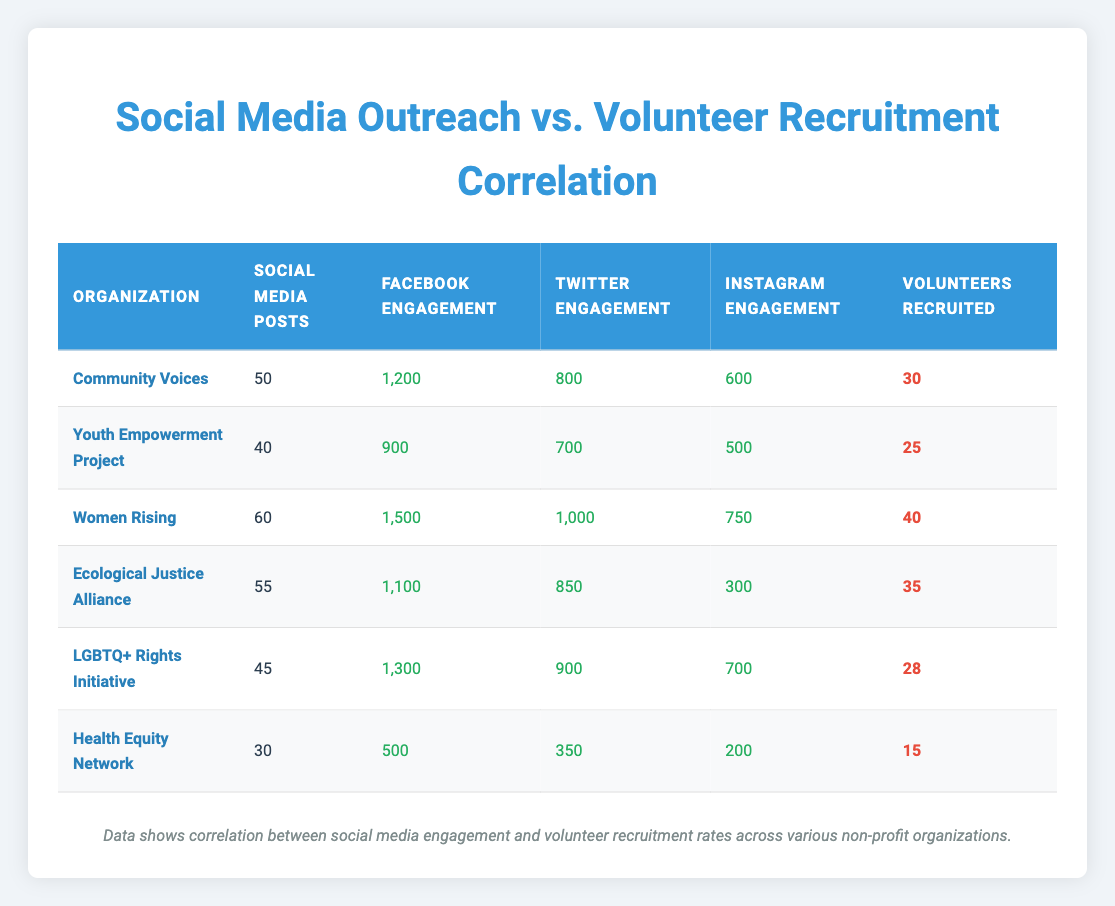What organization has the highest number of volunteers recruited? The table lists the volunteers recruited for each organization. Looking through the numbers, Women Rising has the highest value with 40 volunteers recruited.
Answer: Women Rising What is the total engagement on Facebook for Community Voices? Community Voices has Facebook engagement listed at 1,200. This is a direct retrieval from the table.
Answer: 1,200 What is the average number of social media posts across all organizations? The organizations have 50, 40, 60, 55, 45, and 30 posts respectively. Adding these gives 280. There are 6 organizations, so the average is 280/6 = 46.67.
Answer: 46.67 Is it true that the Health Equity Network has more Twitter engagement than the LGBTQ+ Rights Initiative? The Health Equity Network has 350 Twitter engagements while the LGBTQ+ Rights Initiative has 900. Since 350 is less than 900, the statement is false.
Answer: No Which organization had the lowest number of volunteers recruited, and how many were recruited? The table shows Health Equity Network with the lowest volunteers recruited at 15. This involves comparing the volunteer numbers for all organizations.
Answer: Health Equity Network; 15 What’s the difference in Instagram engagement between Women Rising and Ecological Justice Alliance? Women Rising has 750 Instagram engagements while Ecological Justice Alliance has 300. The difference is calculated by subtracting: 750 - 300 = 450.
Answer: 450 What percentage of volunteers recruited by Ecological Justice Alliance is compared to Women Rising? Women Rising has 40 volunteers, and Ecological Justice Alliance has 35. To find the percentage, calculate (35/40) * 100, which equals 87.5%.
Answer: 87.5% Which organization has the highest combined social media engagement across Facebook, Twitter, and Instagram? We need to sum the engagement numbers for each platform: for Women Rising: 1500 + 1000 + 750 = 3250. Doing this for all organizations, Women Rising has the highest total social media engagement, showing a direct comparison.
Answer: Women Rising How many organizations have recruited more than 30 volunteers? Referring to the table, organizations that recruited more than 30 volunteers are Women Rising (40) and Ecological Justice Alliance (35). This gives a total of 2 organizations.
Answer: 2 